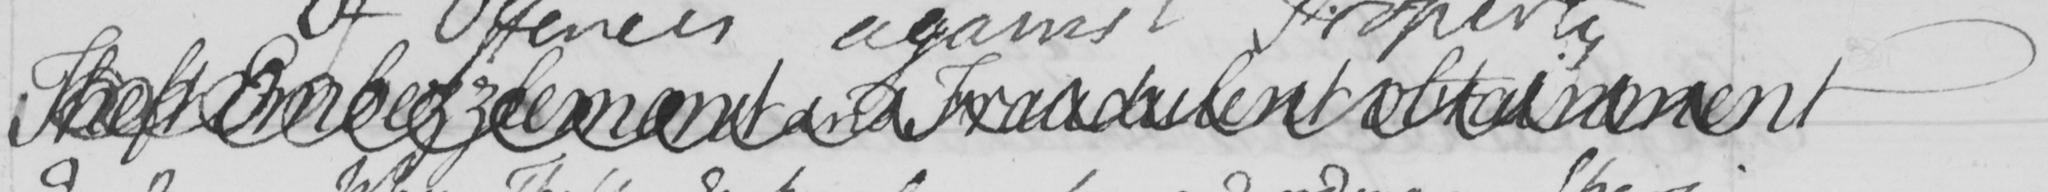Can you tell me what this handwritten text says? Theft Embezzlement and Fraudulent Obtainment 